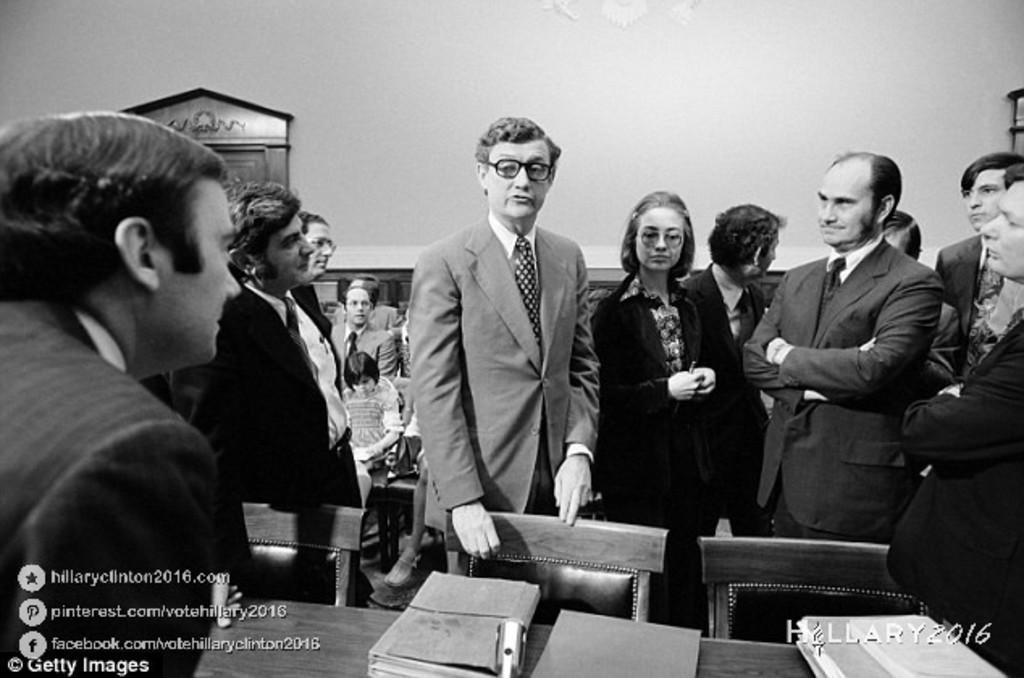Please provide a concise description of this image. In this picture I can see few people standing and few are standing and I can see books on the table and I can see text at the bottom left and bottom right corners of the picture. 